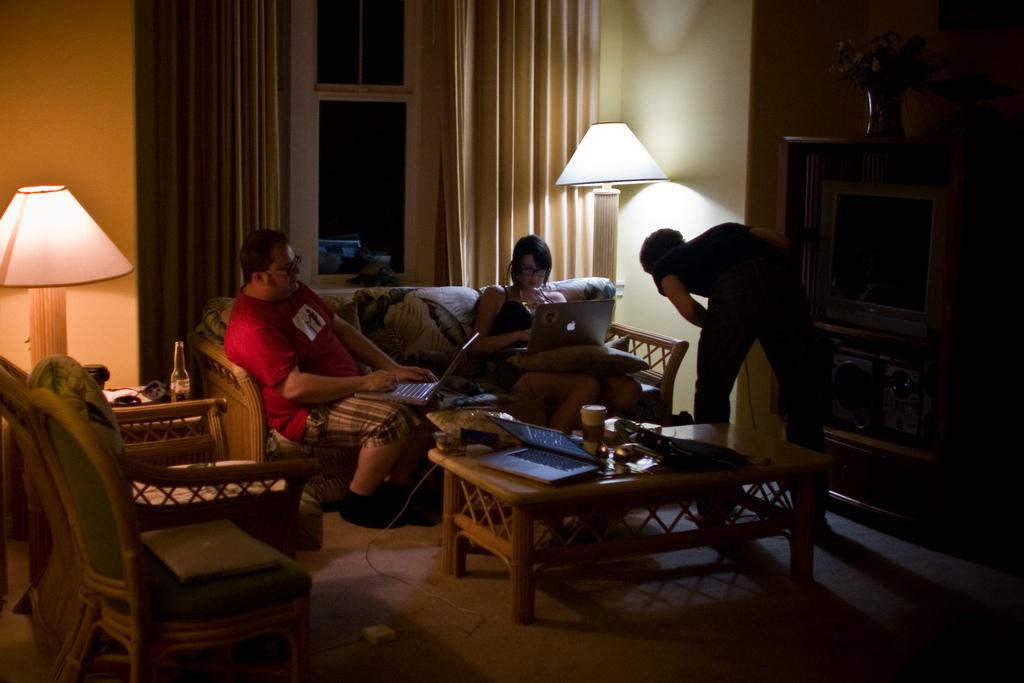How many people are sitting on the sofa in the image? There are two persons sitting on the sofa in the image. What is one of the persons doing while sitting on the sofa? One of the persons is operating a laptop. Can you describe the position of the other person in the image? There is another person standing beside the sofa. What is present in front of the sofa? There is a table in front of the sofa. What object is on the table? There is a laptop on the table. What type of lettuce is being used as a cover for the laptop on the table? There is no lettuce present in the image, and the laptop is not covered by any lettuce. What type of music can be heard coming from the laptop in the image? There is no indication of any music being played in the image, as it only shows two persons sitting on a sofa and a laptop on a table. 